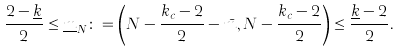<formula> <loc_0><loc_0><loc_500><loc_500>\frac { 2 - \underline { k } } { 2 } \leq \underline { m } _ { N } \colon = \left ( N - \frac { k _ { c } - 2 } { 2 } - \bar { m } , N - \frac { k _ { c } - 2 } { 2 } \right ) \leq \frac { \underline { k } - 2 } { 2 } .</formula> 